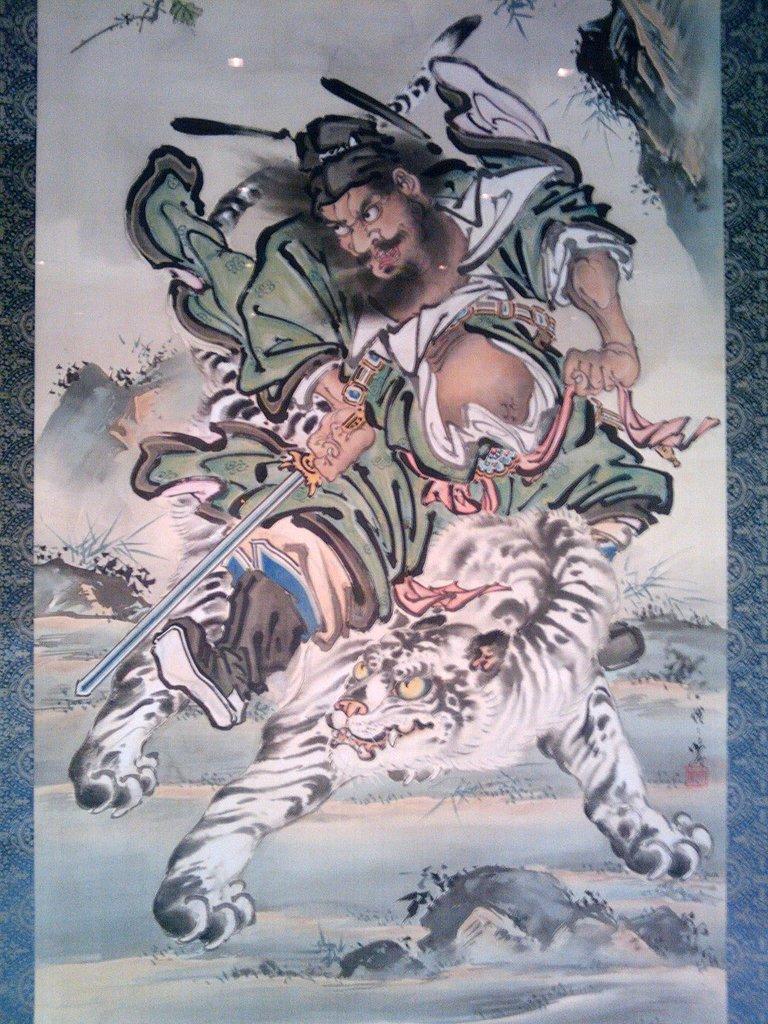Describe this image in one or two sentences. It is an animated picture. Here we can see a person is holding a weapon and sitting on an animal. Here we can see planets and sky. 